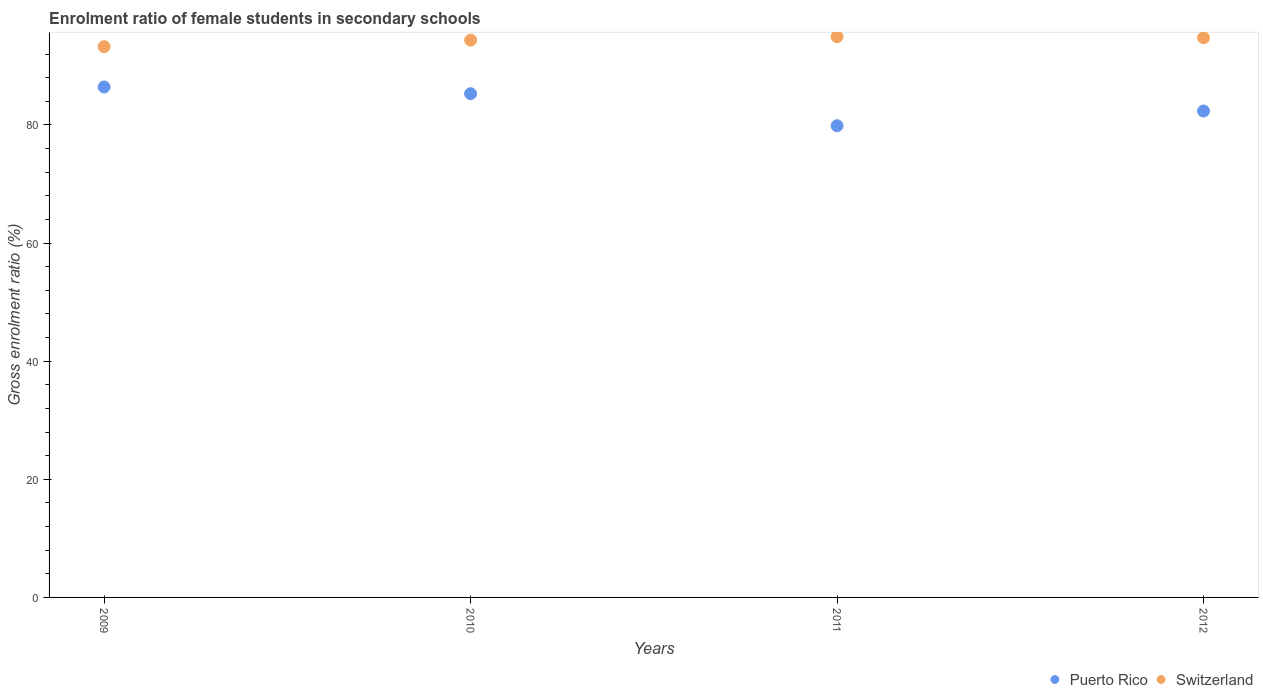How many different coloured dotlines are there?
Your answer should be very brief. 2. Is the number of dotlines equal to the number of legend labels?
Keep it short and to the point. Yes. What is the enrolment ratio of female students in secondary schools in Switzerland in 2012?
Provide a short and direct response. 94.75. Across all years, what is the maximum enrolment ratio of female students in secondary schools in Puerto Rico?
Ensure brevity in your answer.  86.42. Across all years, what is the minimum enrolment ratio of female students in secondary schools in Puerto Rico?
Give a very brief answer. 79.85. In which year was the enrolment ratio of female students in secondary schools in Switzerland maximum?
Keep it short and to the point. 2011. In which year was the enrolment ratio of female students in secondary schools in Puerto Rico minimum?
Make the answer very short. 2011. What is the total enrolment ratio of female students in secondary schools in Switzerland in the graph?
Your answer should be compact. 377.27. What is the difference between the enrolment ratio of female students in secondary schools in Puerto Rico in 2009 and that in 2012?
Offer a terse response. 4.07. What is the difference between the enrolment ratio of female students in secondary schools in Switzerland in 2011 and the enrolment ratio of female students in secondary schools in Puerto Rico in 2009?
Ensure brevity in your answer.  8.51. What is the average enrolment ratio of female students in secondary schools in Switzerland per year?
Offer a terse response. 94.32. In the year 2010, what is the difference between the enrolment ratio of female students in secondary schools in Switzerland and enrolment ratio of female students in secondary schools in Puerto Rico?
Your answer should be very brief. 9.07. What is the ratio of the enrolment ratio of female students in secondary schools in Puerto Rico in 2009 to that in 2012?
Ensure brevity in your answer.  1.05. Is the enrolment ratio of female students in secondary schools in Switzerland in 2010 less than that in 2011?
Make the answer very short. Yes. Is the difference between the enrolment ratio of female students in secondary schools in Switzerland in 2010 and 2012 greater than the difference between the enrolment ratio of female students in secondary schools in Puerto Rico in 2010 and 2012?
Your answer should be compact. No. What is the difference between the highest and the second highest enrolment ratio of female students in secondary schools in Switzerland?
Your answer should be very brief. 0.18. What is the difference between the highest and the lowest enrolment ratio of female students in secondary schools in Switzerland?
Your answer should be compact. 1.69. In how many years, is the enrolment ratio of female students in secondary schools in Puerto Rico greater than the average enrolment ratio of female students in secondary schools in Puerto Rico taken over all years?
Give a very brief answer. 2. Is the sum of the enrolment ratio of female students in secondary schools in Puerto Rico in 2009 and 2010 greater than the maximum enrolment ratio of female students in secondary schools in Switzerland across all years?
Give a very brief answer. Yes. Is the enrolment ratio of female students in secondary schools in Switzerland strictly greater than the enrolment ratio of female students in secondary schools in Puerto Rico over the years?
Offer a terse response. Yes. How many years are there in the graph?
Give a very brief answer. 4. Does the graph contain grids?
Your answer should be compact. No. How many legend labels are there?
Make the answer very short. 2. How are the legend labels stacked?
Make the answer very short. Horizontal. What is the title of the graph?
Make the answer very short. Enrolment ratio of female students in secondary schools. Does "Senegal" appear as one of the legend labels in the graph?
Ensure brevity in your answer.  No. What is the label or title of the X-axis?
Keep it short and to the point. Years. What is the label or title of the Y-axis?
Offer a terse response. Gross enrolment ratio (%). What is the Gross enrolment ratio (%) of Puerto Rico in 2009?
Your answer should be very brief. 86.42. What is the Gross enrolment ratio (%) in Switzerland in 2009?
Your answer should be very brief. 93.24. What is the Gross enrolment ratio (%) in Puerto Rico in 2010?
Make the answer very short. 85.28. What is the Gross enrolment ratio (%) of Switzerland in 2010?
Your answer should be very brief. 94.35. What is the Gross enrolment ratio (%) of Puerto Rico in 2011?
Your answer should be compact. 79.85. What is the Gross enrolment ratio (%) of Switzerland in 2011?
Your answer should be very brief. 94.93. What is the Gross enrolment ratio (%) of Puerto Rico in 2012?
Keep it short and to the point. 82.35. What is the Gross enrolment ratio (%) in Switzerland in 2012?
Your answer should be compact. 94.75. Across all years, what is the maximum Gross enrolment ratio (%) of Puerto Rico?
Ensure brevity in your answer.  86.42. Across all years, what is the maximum Gross enrolment ratio (%) of Switzerland?
Your response must be concise. 94.93. Across all years, what is the minimum Gross enrolment ratio (%) in Puerto Rico?
Ensure brevity in your answer.  79.85. Across all years, what is the minimum Gross enrolment ratio (%) in Switzerland?
Offer a terse response. 93.24. What is the total Gross enrolment ratio (%) of Puerto Rico in the graph?
Keep it short and to the point. 333.9. What is the total Gross enrolment ratio (%) in Switzerland in the graph?
Offer a terse response. 377.27. What is the difference between the Gross enrolment ratio (%) of Puerto Rico in 2009 and that in 2010?
Offer a very short reply. 1.13. What is the difference between the Gross enrolment ratio (%) of Switzerland in 2009 and that in 2010?
Offer a very short reply. -1.11. What is the difference between the Gross enrolment ratio (%) of Puerto Rico in 2009 and that in 2011?
Keep it short and to the point. 6.56. What is the difference between the Gross enrolment ratio (%) in Switzerland in 2009 and that in 2011?
Your answer should be compact. -1.69. What is the difference between the Gross enrolment ratio (%) in Puerto Rico in 2009 and that in 2012?
Offer a terse response. 4.07. What is the difference between the Gross enrolment ratio (%) of Switzerland in 2009 and that in 2012?
Make the answer very short. -1.5. What is the difference between the Gross enrolment ratio (%) in Puerto Rico in 2010 and that in 2011?
Offer a very short reply. 5.43. What is the difference between the Gross enrolment ratio (%) in Switzerland in 2010 and that in 2011?
Offer a very short reply. -0.58. What is the difference between the Gross enrolment ratio (%) in Puerto Rico in 2010 and that in 2012?
Your answer should be very brief. 2.94. What is the difference between the Gross enrolment ratio (%) of Switzerland in 2010 and that in 2012?
Your answer should be very brief. -0.39. What is the difference between the Gross enrolment ratio (%) in Puerto Rico in 2011 and that in 2012?
Your response must be concise. -2.49. What is the difference between the Gross enrolment ratio (%) of Switzerland in 2011 and that in 2012?
Provide a short and direct response. 0.18. What is the difference between the Gross enrolment ratio (%) of Puerto Rico in 2009 and the Gross enrolment ratio (%) of Switzerland in 2010?
Provide a short and direct response. -7.94. What is the difference between the Gross enrolment ratio (%) in Puerto Rico in 2009 and the Gross enrolment ratio (%) in Switzerland in 2011?
Offer a terse response. -8.51. What is the difference between the Gross enrolment ratio (%) of Puerto Rico in 2009 and the Gross enrolment ratio (%) of Switzerland in 2012?
Provide a short and direct response. -8.33. What is the difference between the Gross enrolment ratio (%) in Puerto Rico in 2010 and the Gross enrolment ratio (%) in Switzerland in 2011?
Offer a terse response. -9.65. What is the difference between the Gross enrolment ratio (%) of Puerto Rico in 2010 and the Gross enrolment ratio (%) of Switzerland in 2012?
Keep it short and to the point. -9.46. What is the difference between the Gross enrolment ratio (%) of Puerto Rico in 2011 and the Gross enrolment ratio (%) of Switzerland in 2012?
Give a very brief answer. -14.89. What is the average Gross enrolment ratio (%) in Puerto Rico per year?
Make the answer very short. 83.47. What is the average Gross enrolment ratio (%) of Switzerland per year?
Offer a very short reply. 94.32. In the year 2009, what is the difference between the Gross enrolment ratio (%) of Puerto Rico and Gross enrolment ratio (%) of Switzerland?
Make the answer very short. -6.83. In the year 2010, what is the difference between the Gross enrolment ratio (%) in Puerto Rico and Gross enrolment ratio (%) in Switzerland?
Your answer should be very brief. -9.07. In the year 2011, what is the difference between the Gross enrolment ratio (%) in Puerto Rico and Gross enrolment ratio (%) in Switzerland?
Ensure brevity in your answer.  -15.08. In the year 2012, what is the difference between the Gross enrolment ratio (%) in Puerto Rico and Gross enrolment ratio (%) in Switzerland?
Your response must be concise. -12.4. What is the ratio of the Gross enrolment ratio (%) of Puerto Rico in 2009 to that in 2010?
Give a very brief answer. 1.01. What is the ratio of the Gross enrolment ratio (%) in Switzerland in 2009 to that in 2010?
Make the answer very short. 0.99. What is the ratio of the Gross enrolment ratio (%) of Puerto Rico in 2009 to that in 2011?
Your answer should be very brief. 1.08. What is the ratio of the Gross enrolment ratio (%) in Switzerland in 2009 to that in 2011?
Make the answer very short. 0.98. What is the ratio of the Gross enrolment ratio (%) in Puerto Rico in 2009 to that in 2012?
Offer a terse response. 1.05. What is the ratio of the Gross enrolment ratio (%) in Switzerland in 2009 to that in 2012?
Offer a very short reply. 0.98. What is the ratio of the Gross enrolment ratio (%) in Puerto Rico in 2010 to that in 2011?
Your response must be concise. 1.07. What is the ratio of the Gross enrolment ratio (%) of Puerto Rico in 2010 to that in 2012?
Provide a short and direct response. 1.04. What is the ratio of the Gross enrolment ratio (%) of Switzerland in 2010 to that in 2012?
Offer a terse response. 1. What is the ratio of the Gross enrolment ratio (%) in Puerto Rico in 2011 to that in 2012?
Provide a succinct answer. 0.97. What is the difference between the highest and the second highest Gross enrolment ratio (%) in Puerto Rico?
Provide a short and direct response. 1.13. What is the difference between the highest and the second highest Gross enrolment ratio (%) in Switzerland?
Your answer should be very brief. 0.18. What is the difference between the highest and the lowest Gross enrolment ratio (%) of Puerto Rico?
Offer a very short reply. 6.56. What is the difference between the highest and the lowest Gross enrolment ratio (%) of Switzerland?
Give a very brief answer. 1.69. 